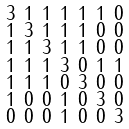<formula> <loc_0><loc_0><loc_500><loc_500>\begin{smallmatrix} 3 & 1 & 1 & 1 & 1 & 1 & 0 \\ 1 & 3 & 1 & 1 & 1 & 0 & 0 \\ 1 & 1 & 3 & 1 & 1 & 0 & 0 \\ 1 & 1 & 1 & 3 & 0 & 1 & 1 \\ 1 & 1 & 1 & 0 & 3 & 0 & 0 \\ 1 & 0 & 0 & 1 & 0 & 3 & 0 \\ 0 & 0 & 0 & 1 & 0 & 0 & 3 \end{smallmatrix}</formula> 